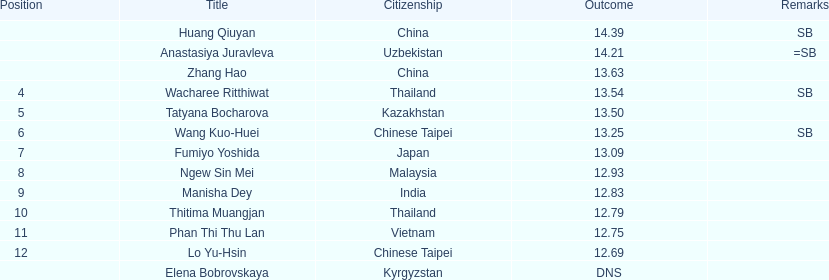What is the difference between huang qiuyan's result and fumiyo yoshida's result? 1.3. 